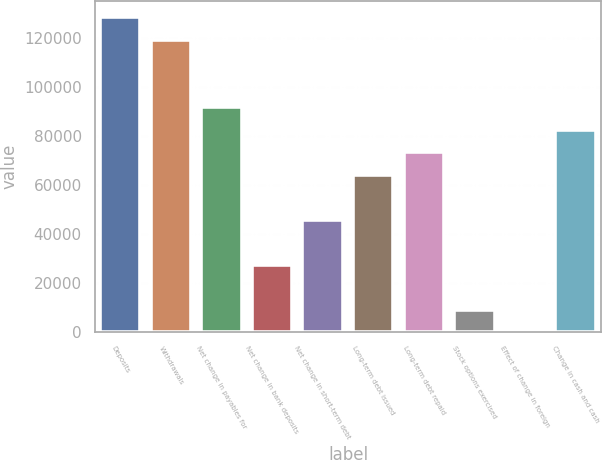<chart> <loc_0><loc_0><loc_500><loc_500><bar_chart><fcel>Deposits<fcel>Withdrawals<fcel>Net change in payables for<fcel>Net change in bank deposits<fcel>Net change in short-term debt<fcel>Long-term debt issued<fcel>Long-term debt repaid<fcel>Stock options exercised<fcel>Effect of change in foreign<fcel>Change in cash and cash<nl><fcel>128716<fcel>119523<fcel>91946<fcel>27599.2<fcel>45984<fcel>64368.8<fcel>73561.2<fcel>9214.4<fcel>22<fcel>82753.6<nl></chart> 